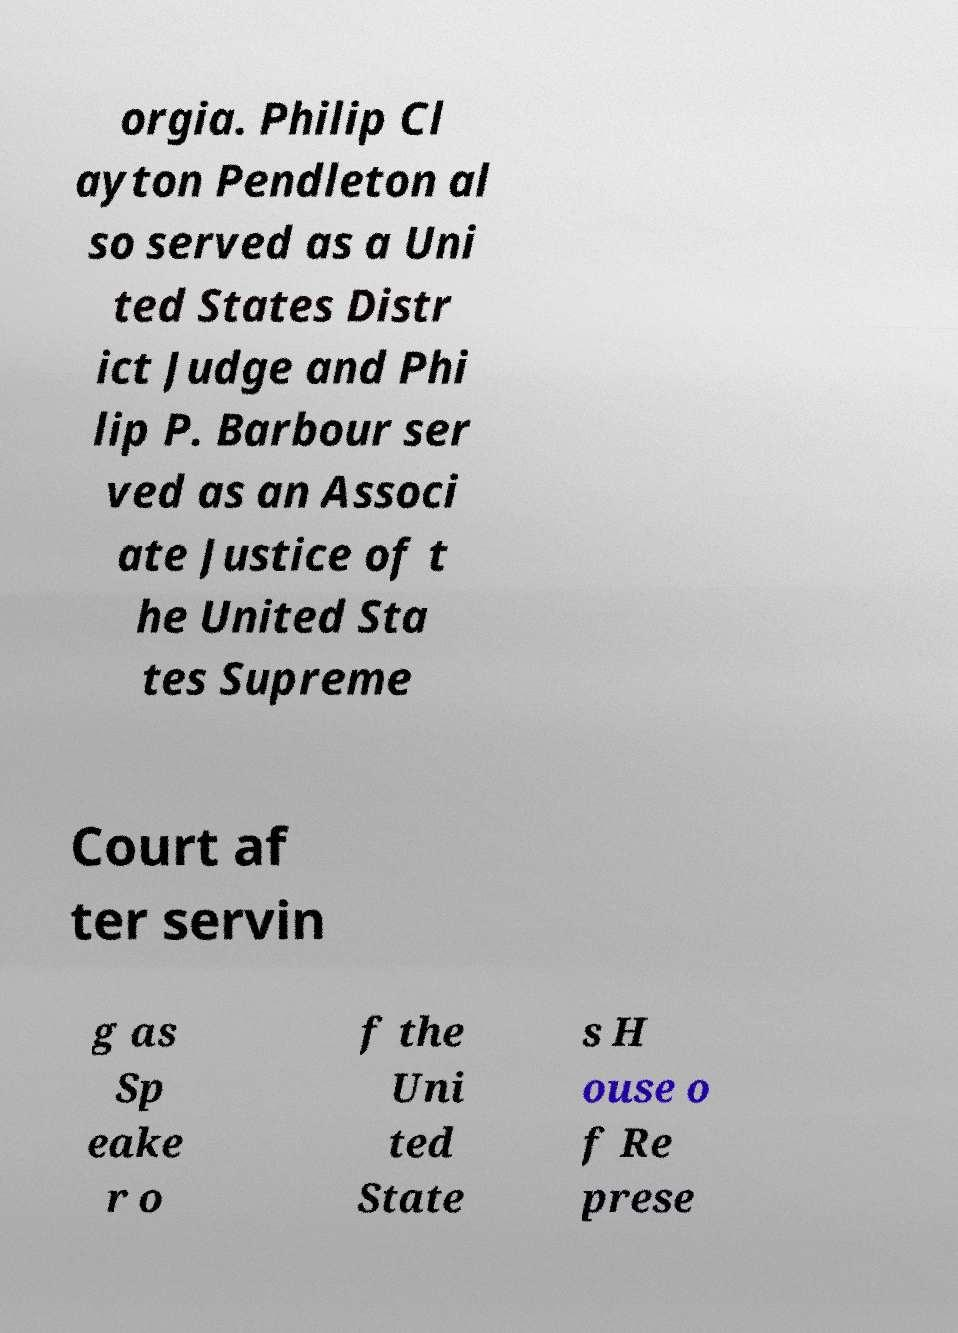Can you accurately transcribe the text from the provided image for me? orgia. Philip Cl ayton Pendleton al so served as a Uni ted States Distr ict Judge and Phi lip P. Barbour ser ved as an Associ ate Justice of t he United Sta tes Supreme Court af ter servin g as Sp eake r o f the Uni ted State s H ouse o f Re prese 